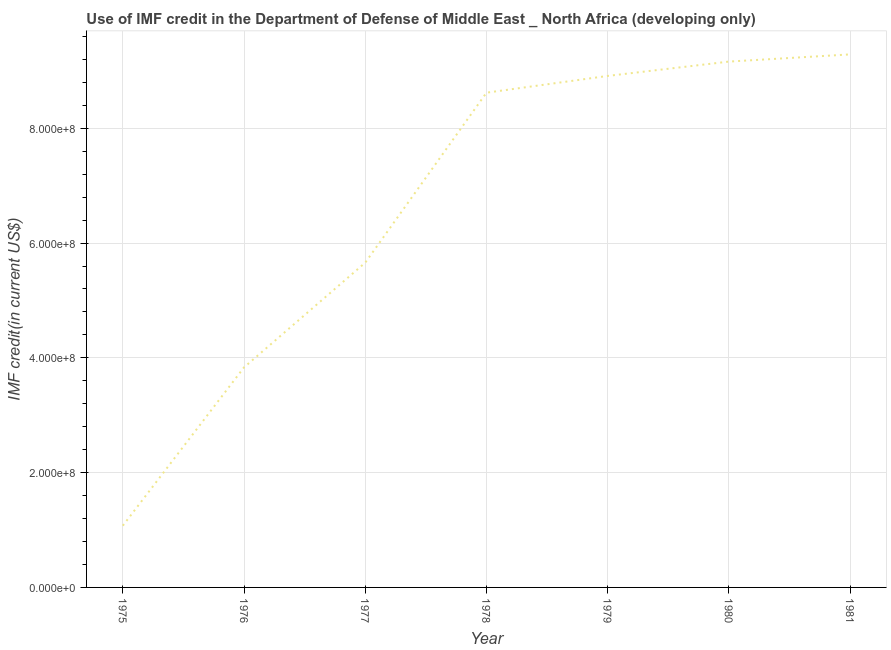What is the use of imf credit in dod in 1977?
Ensure brevity in your answer.  5.66e+08. Across all years, what is the maximum use of imf credit in dod?
Provide a short and direct response. 9.29e+08. Across all years, what is the minimum use of imf credit in dod?
Offer a very short reply. 1.08e+08. In which year was the use of imf credit in dod maximum?
Make the answer very short. 1981. In which year was the use of imf credit in dod minimum?
Make the answer very short. 1975. What is the sum of the use of imf credit in dod?
Offer a terse response. 4.66e+09. What is the difference between the use of imf credit in dod in 1975 and 1977?
Your answer should be compact. -4.58e+08. What is the average use of imf credit in dod per year?
Offer a very short reply. 6.65e+08. What is the median use of imf credit in dod?
Provide a succinct answer. 8.62e+08. Do a majority of the years between 1975 and 1977 (inclusive) have use of imf credit in dod greater than 680000000 US$?
Offer a terse response. No. What is the ratio of the use of imf credit in dod in 1977 to that in 1979?
Provide a succinct answer. 0.63. Is the use of imf credit in dod in 1976 less than that in 1978?
Ensure brevity in your answer.  Yes. Is the difference between the use of imf credit in dod in 1979 and 1981 greater than the difference between any two years?
Keep it short and to the point. No. What is the difference between the highest and the second highest use of imf credit in dod?
Keep it short and to the point. 1.26e+07. What is the difference between the highest and the lowest use of imf credit in dod?
Make the answer very short. 8.21e+08. In how many years, is the use of imf credit in dod greater than the average use of imf credit in dod taken over all years?
Keep it short and to the point. 4. Does the use of imf credit in dod monotonically increase over the years?
Provide a short and direct response. Yes. How many years are there in the graph?
Your answer should be very brief. 7. Does the graph contain grids?
Ensure brevity in your answer.  Yes. What is the title of the graph?
Your answer should be compact. Use of IMF credit in the Department of Defense of Middle East _ North Africa (developing only). What is the label or title of the X-axis?
Provide a succinct answer. Year. What is the label or title of the Y-axis?
Keep it short and to the point. IMF credit(in current US$). What is the IMF credit(in current US$) of 1975?
Ensure brevity in your answer.  1.08e+08. What is the IMF credit(in current US$) of 1976?
Ensure brevity in your answer.  3.83e+08. What is the IMF credit(in current US$) of 1977?
Make the answer very short. 5.66e+08. What is the IMF credit(in current US$) of 1978?
Make the answer very short. 8.62e+08. What is the IMF credit(in current US$) in 1979?
Offer a very short reply. 8.91e+08. What is the IMF credit(in current US$) in 1980?
Offer a very short reply. 9.16e+08. What is the IMF credit(in current US$) of 1981?
Make the answer very short. 9.29e+08. What is the difference between the IMF credit(in current US$) in 1975 and 1976?
Your answer should be compact. -2.76e+08. What is the difference between the IMF credit(in current US$) in 1975 and 1977?
Ensure brevity in your answer.  -4.58e+08. What is the difference between the IMF credit(in current US$) in 1975 and 1978?
Offer a very short reply. -7.54e+08. What is the difference between the IMF credit(in current US$) in 1975 and 1979?
Make the answer very short. -7.84e+08. What is the difference between the IMF credit(in current US$) in 1975 and 1980?
Provide a succinct answer. -8.09e+08. What is the difference between the IMF credit(in current US$) in 1975 and 1981?
Provide a short and direct response. -8.21e+08. What is the difference between the IMF credit(in current US$) in 1976 and 1977?
Your answer should be very brief. -1.83e+08. What is the difference between the IMF credit(in current US$) in 1976 and 1978?
Offer a terse response. -4.79e+08. What is the difference between the IMF credit(in current US$) in 1976 and 1979?
Offer a terse response. -5.08e+08. What is the difference between the IMF credit(in current US$) in 1976 and 1980?
Your answer should be very brief. -5.33e+08. What is the difference between the IMF credit(in current US$) in 1976 and 1981?
Provide a short and direct response. -5.45e+08. What is the difference between the IMF credit(in current US$) in 1977 and 1978?
Offer a very short reply. -2.96e+08. What is the difference between the IMF credit(in current US$) in 1977 and 1979?
Provide a short and direct response. -3.25e+08. What is the difference between the IMF credit(in current US$) in 1977 and 1980?
Give a very brief answer. -3.50e+08. What is the difference between the IMF credit(in current US$) in 1977 and 1981?
Provide a short and direct response. -3.63e+08. What is the difference between the IMF credit(in current US$) in 1978 and 1979?
Provide a succinct answer. -2.92e+07. What is the difference between the IMF credit(in current US$) in 1978 and 1980?
Your response must be concise. -5.42e+07. What is the difference between the IMF credit(in current US$) in 1978 and 1981?
Ensure brevity in your answer.  -6.67e+07. What is the difference between the IMF credit(in current US$) in 1979 and 1980?
Your response must be concise. -2.50e+07. What is the difference between the IMF credit(in current US$) in 1979 and 1981?
Provide a succinct answer. -3.75e+07. What is the difference between the IMF credit(in current US$) in 1980 and 1981?
Keep it short and to the point. -1.26e+07. What is the ratio of the IMF credit(in current US$) in 1975 to that in 1976?
Your response must be concise. 0.28. What is the ratio of the IMF credit(in current US$) in 1975 to that in 1977?
Your answer should be very brief. 0.19. What is the ratio of the IMF credit(in current US$) in 1975 to that in 1978?
Your response must be concise. 0.12. What is the ratio of the IMF credit(in current US$) in 1975 to that in 1979?
Make the answer very short. 0.12. What is the ratio of the IMF credit(in current US$) in 1975 to that in 1980?
Give a very brief answer. 0.12. What is the ratio of the IMF credit(in current US$) in 1975 to that in 1981?
Make the answer very short. 0.12. What is the ratio of the IMF credit(in current US$) in 1976 to that in 1977?
Your answer should be compact. 0.68. What is the ratio of the IMF credit(in current US$) in 1976 to that in 1978?
Make the answer very short. 0.45. What is the ratio of the IMF credit(in current US$) in 1976 to that in 1979?
Ensure brevity in your answer.  0.43. What is the ratio of the IMF credit(in current US$) in 1976 to that in 1980?
Keep it short and to the point. 0.42. What is the ratio of the IMF credit(in current US$) in 1976 to that in 1981?
Give a very brief answer. 0.41. What is the ratio of the IMF credit(in current US$) in 1977 to that in 1978?
Your answer should be very brief. 0.66. What is the ratio of the IMF credit(in current US$) in 1977 to that in 1979?
Make the answer very short. 0.64. What is the ratio of the IMF credit(in current US$) in 1977 to that in 1980?
Offer a very short reply. 0.62. What is the ratio of the IMF credit(in current US$) in 1977 to that in 1981?
Make the answer very short. 0.61. What is the ratio of the IMF credit(in current US$) in 1978 to that in 1980?
Your answer should be compact. 0.94. What is the ratio of the IMF credit(in current US$) in 1978 to that in 1981?
Your answer should be compact. 0.93. What is the ratio of the IMF credit(in current US$) in 1979 to that in 1981?
Keep it short and to the point. 0.96. What is the ratio of the IMF credit(in current US$) in 1980 to that in 1981?
Your answer should be compact. 0.99. 